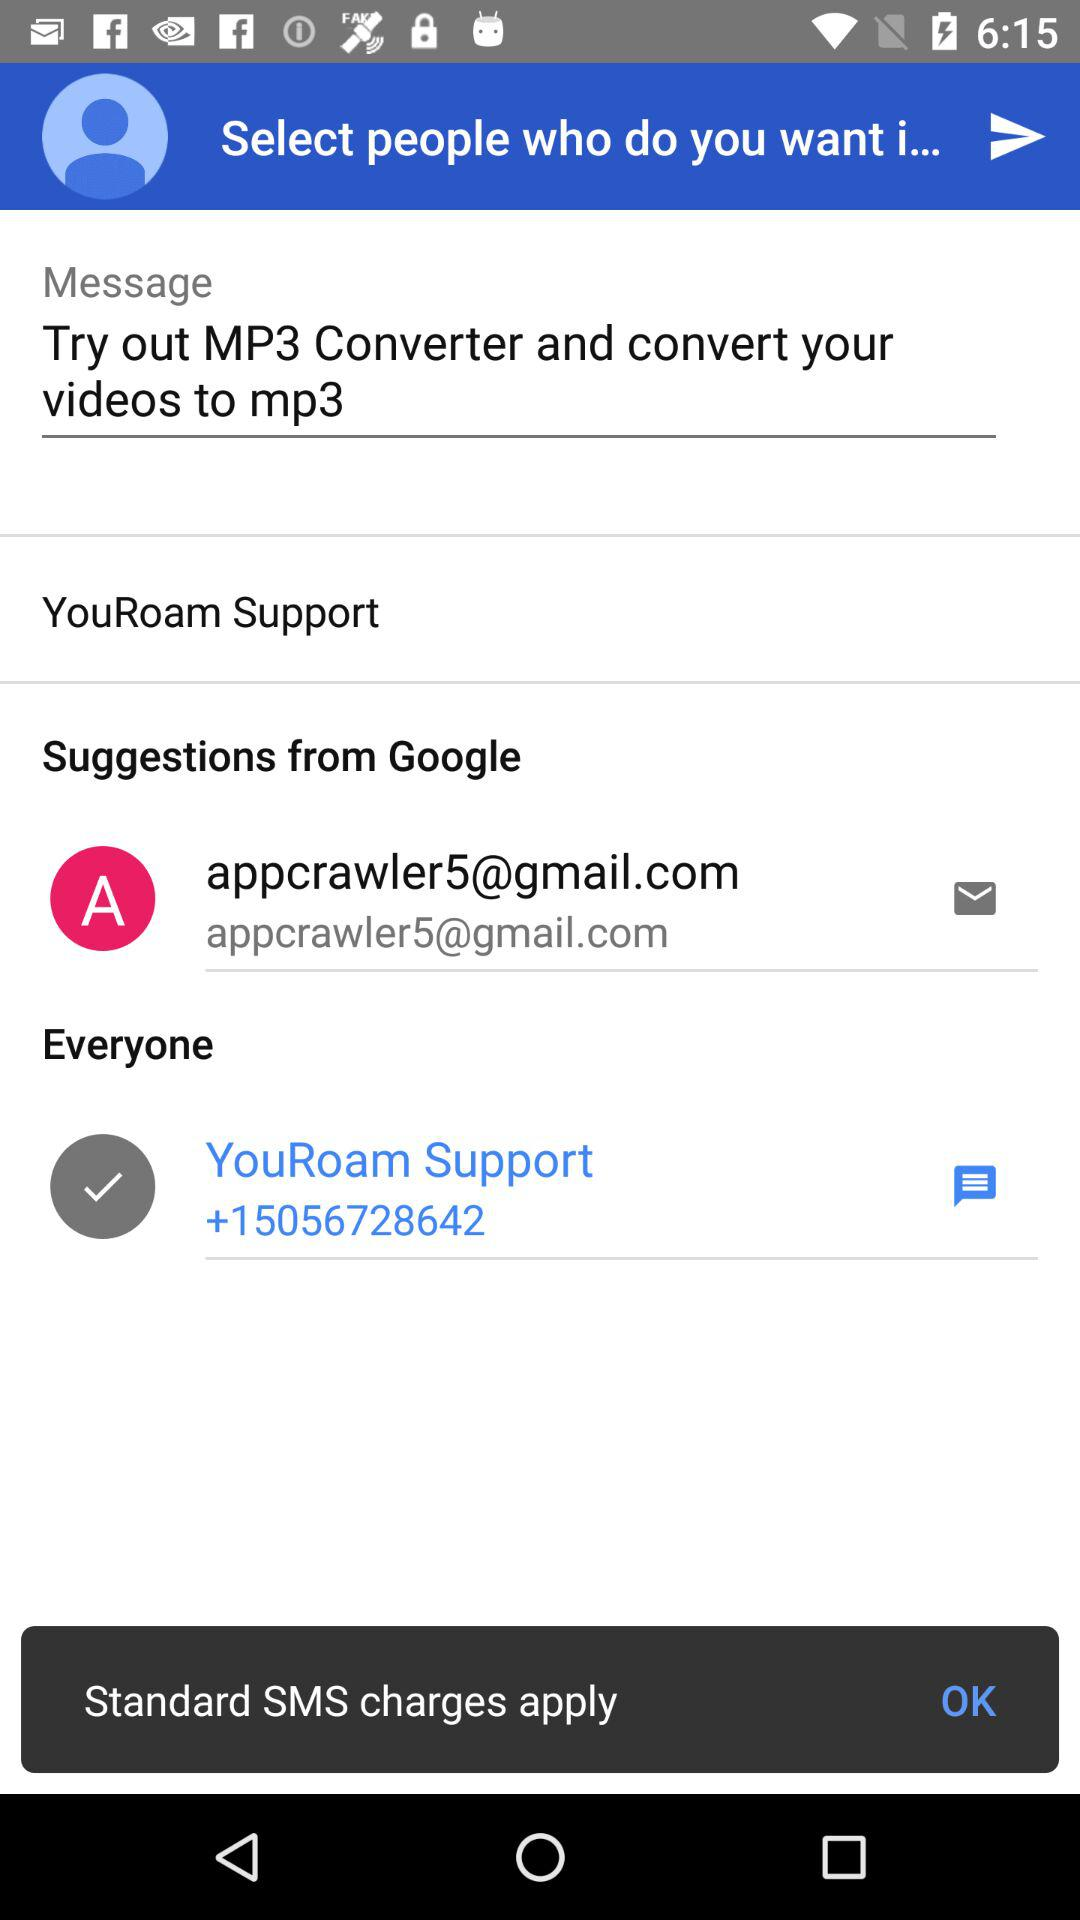What text is written in the message box? The text written in the message box is "Try out MP3 Converter and convert your videos to mp3". 